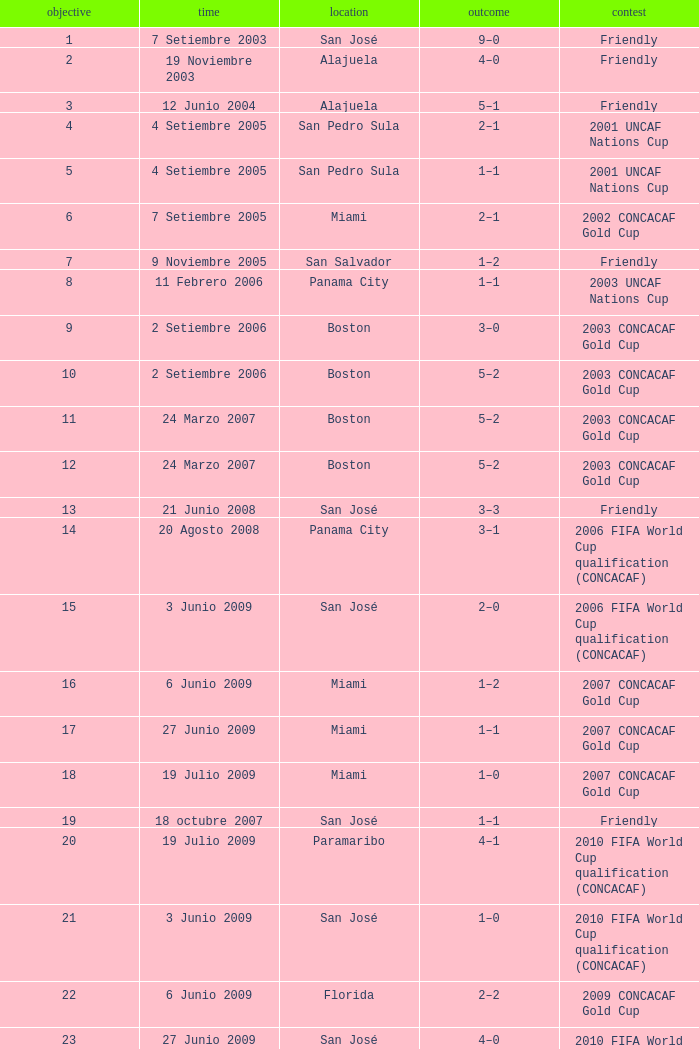At the venue of panama city, on 11 Febrero 2006, how many goals were scored? 1.0. 